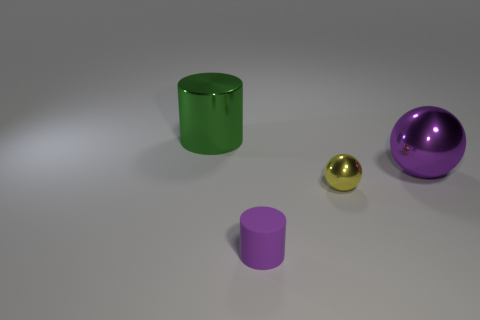Add 1 small purple rubber cylinders. How many objects exist? 5 Subtract 1 purple cylinders. How many objects are left? 3 Subtract all yellow things. Subtract all big purple objects. How many objects are left? 2 Add 4 big things. How many big things are left? 6 Add 1 tiny blue things. How many tiny blue things exist? 1 